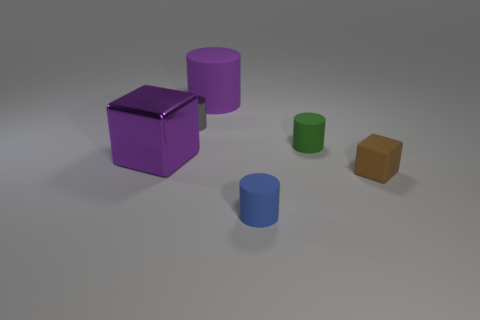There is a purple object left of the large object on the right side of the purple cube; what is it made of?
Make the answer very short. Metal. What is the shape of the big thing that is the same material as the tiny gray thing?
Keep it short and to the point. Cube. Is there any other thing that has the same shape as the brown matte object?
Your answer should be very brief. Yes. What number of tiny rubber cylinders are left of the purple metallic thing?
Offer a very short reply. 0. Is there a small cyan matte sphere?
Your answer should be compact. No. There is a metallic object behind the small rubber object behind the cube that is left of the brown object; what color is it?
Provide a short and direct response. Gray. There is a green object in front of the gray cylinder; is there a metal cylinder to the right of it?
Give a very brief answer. No. There is a matte cylinder that is in front of the matte cube; is it the same color as the small matte object that is behind the big purple metal object?
Your response must be concise. No. How many blue objects are the same size as the metallic cylinder?
Give a very brief answer. 1. Is the size of the rubber cylinder in front of the green matte cylinder the same as the green thing?
Provide a succinct answer. Yes. 